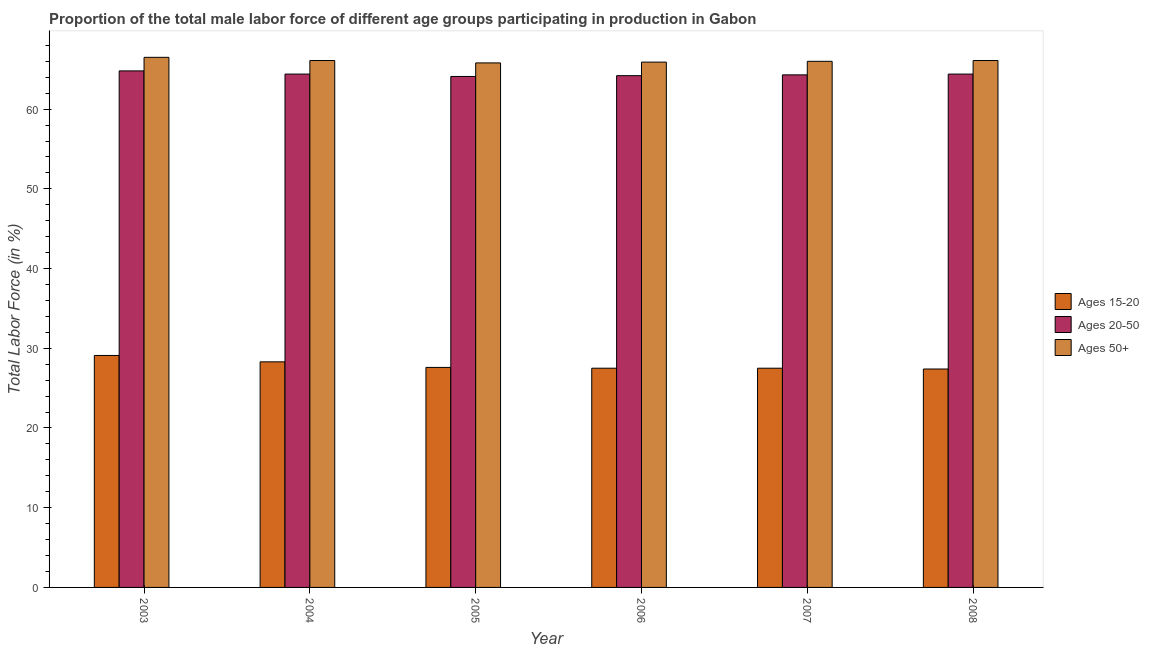How many different coloured bars are there?
Your answer should be very brief. 3. Are the number of bars per tick equal to the number of legend labels?
Provide a succinct answer. Yes. What is the percentage of male labor force above age 50 in 2003?
Provide a short and direct response. 66.5. Across all years, what is the maximum percentage of male labor force within the age group 20-50?
Provide a short and direct response. 64.8. Across all years, what is the minimum percentage of male labor force above age 50?
Your response must be concise. 65.8. In which year was the percentage of male labor force within the age group 15-20 minimum?
Your answer should be compact. 2008. What is the total percentage of male labor force within the age group 15-20 in the graph?
Ensure brevity in your answer.  167.4. What is the difference between the percentage of male labor force within the age group 15-20 in 2005 and that in 2006?
Keep it short and to the point. 0.1. What is the difference between the percentage of male labor force above age 50 in 2007 and the percentage of male labor force within the age group 20-50 in 2004?
Make the answer very short. -0.1. What is the average percentage of male labor force above age 50 per year?
Keep it short and to the point. 66.07. In the year 2008, what is the difference between the percentage of male labor force within the age group 20-50 and percentage of male labor force above age 50?
Offer a very short reply. 0. In how many years, is the percentage of male labor force above age 50 greater than 30 %?
Ensure brevity in your answer.  6. What is the ratio of the percentage of male labor force within the age group 20-50 in 2006 to that in 2007?
Offer a very short reply. 1. What is the difference between the highest and the second highest percentage of male labor force within the age group 20-50?
Give a very brief answer. 0.4. What is the difference between the highest and the lowest percentage of male labor force within the age group 20-50?
Offer a terse response. 0.7. In how many years, is the percentage of male labor force above age 50 greater than the average percentage of male labor force above age 50 taken over all years?
Offer a terse response. 3. What does the 1st bar from the left in 2006 represents?
Give a very brief answer. Ages 15-20. What does the 3rd bar from the right in 2003 represents?
Offer a very short reply. Ages 15-20. What is the difference between two consecutive major ticks on the Y-axis?
Make the answer very short. 10. Are the values on the major ticks of Y-axis written in scientific E-notation?
Give a very brief answer. No. Does the graph contain grids?
Make the answer very short. No. What is the title of the graph?
Keep it short and to the point. Proportion of the total male labor force of different age groups participating in production in Gabon. Does "Nuclear sources" appear as one of the legend labels in the graph?
Your answer should be very brief. No. What is the Total Labor Force (in %) in Ages 15-20 in 2003?
Keep it short and to the point. 29.1. What is the Total Labor Force (in %) of Ages 20-50 in 2003?
Provide a succinct answer. 64.8. What is the Total Labor Force (in %) of Ages 50+ in 2003?
Your answer should be compact. 66.5. What is the Total Labor Force (in %) in Ages 15-20 in 2004?
Provide a succinct answer. 28.3. What is the Total Labor Force (in %) of Ages 20-50 in 2004?
Offer a terse response. 64.4. What is the Total Labor Force (in %) of Ages 50+ in 2004?
Your answer should be compact. 66.1. What is the Total Labor Force (in %) in Ages 15-20 in 2005?
Ensure brevity in your answer.  27.6. What is the Total Labor Force (in %) of Ages 20-50 in 2005?
Offer a terse response. 64.1. What is the Total Labor Force (in %) of Ages 50+ in 2005?
Offer a very short reply. 65.8. What is the Total Labor Force (in %) of Ages 15-20 in 2006?
Ensure brevity in your answer.  27.5. What is the Total Labor Force (in %) in Ages 20-50 in 2006?
Offer a very short reply. 64.2. What is the Total Labor Force (in %) in Ages 50+ in 2006?
Keep it short and to the point. 65.9. What is the Total Labor Force (in %) in Ages 15-20 in 2007?
Your response must be concise. 27.5. What is the Total Labor Force (in %) in Ages 20-50 in 2007?
Your answer should be very brief. 64.3. What is the Total Labor Force (in %) of Ages 50+ in 2007?
Make the answer very short. 66. What is the Total Labor Force (in %) in Ages 15-20 in 2008?
Your response must be concise. 27.4. What is the Total Labor Force (in %) in Ages 20-50 in 2008?
Your answer should be compact. 64.4. What is the Total Labor Force (in %) of Ages 50+ in 2008?
Offer a very short reply. 66.1. Across all years, what is the maximum Total Labor Force (in %) of Ages 15-20?
Provide a short and direct response. 29.1. Across all years, what is the maximum Total Labor Force (in %) in Ages 20-50?
Make the answer very short. 64.8. Across all years, what is the maximum Total Labor Force (in %) of Ages 50+?
Your answer should be compact. 66.5. Across all years, what is the minimum Total Labor Force (in %) of Ages 15-20?
Offer a terse response. 27.4. Across all years, what is the minimum Total Labor Force (in %) of Ages 20-50?
Keep it short and to the point. 64.1. Across all years, what is the minimum Total Labor Force (in %) of Ages 50+?
Your answer should be compact. 65.8. What is the total Total Labor Force (in %) in Ages 15-20 in the graph?
Give a very brief answer. 167.4. What is the total Total Labor Force (in %) in Ages 20-50 in the graph?
Make the answer very short. 386.2. What is the total Total Labor Force (in %) in Ages 50+ in the graph?
Your response must be concise. 396.4. What is the difference between the Total Labor Force (in %) of Ages 15-20 in 2003 and that in 2004?
Provide a succinct answer. 0.8. What is the difference between the Total Labor Force (in %) of Ages 50+ in 2003 and that in 2004?
Provide a succinct answer. 0.4. What is the difference between the Total Labor Force (in %) of Ages 15-20 in 2003 and that in 2005?
Make the answer very short. 1.5. What is the difference between the Total Labor Force (in %) of Ages 50+ in 2003 and that in 2005?
Your answer should be compact. 0.7. What is the difference between the Total Labor Force (in %) of Ages 20-50 in 2003 and that in 2007?
Offer a very short reply. 0.5. What is the difference between the Total Labor Force (in %) of Ages 50+ in 2003 and that in 2007?
Provide a short and direct response. 0.5. What is the difference between the Total Labor Force (in %) of Ages 20-50 in 2003 and that in 2008?
Provide a succinct answer. 0.4. What is the difference between the Total Labor Force (in %) of Ages 50+ in 2003 and that in 2008?
Keep it short and to the point. 0.4. What is the difference between the Total Labor Force (in %) in Ages 15-20 in 2004 and that in 2005?
Give a very brief answer. 0.7. What is the difference between the Total Labor Force (in %) in Ages 50+ in 2004 and that in 2005?
Your response must be concise. 0.3. What is the difference between the Total Labor Force (in %) of Ages 15-20 in 2004 and that in 2006?
Offer a terse response. 0.8. What is the difference between the Total Labor Force (in %) in Ages 50+ in 2004 and that in 2006?
Provide a short and direct response. 0.2. What is the difference between the Total Labor Force (in %) of Ages 20-50 in 2004 and that in 2007?
Offer a very short reply. 0.1. What is the difference between the Total Labor Force (in %) of Ages 50+ in 2004 and that in 2007?
Give a very brief answer. 0.1. What is the difference between the Total Labor Force (in %) of Ages 15-20 in 2004 and that in 2008?
Keep it short and to the point. 0.9. What is the difference between the Total Labor Force (in %) of Ages 50+ in 2004 and that in 2008?
Your response must be concise. 0. What is the difference between the Total Labor Force (in %) in Ages 20-50 in 2005 and that in 2006?
Make the answer very short. -0.1. What is the difference between the Total Labor Force (in %) of Ages 50+ in 2005 and that in 2006?
Give a very brief answer. -0.1. What is the difference between the Total Labor Force (in %) in Ages 15-20 in 2005 and that in 2007?
Provide a short and direct response. 0.1. What is the difference between the Total Labor Force (in %) of Ages 20-50 in 2005 and that in 2007?
Your answer should be very brief. -0.2. What is the difference between the Total Labor Force (in %) of Ages 20-50 in 2005 and that in 2008?
Offer a very short reply. -0.3. What is the difference between the Total Labor Force (in %) in Ages 50+ in 2005 and that in 2008?
Your answer should be very brief. -0.3. What is the difference between the Total Labor Force (in %) in Ages 15-20 in 2006 and that in 2007?
Provide a succinct answer. 0. What is the difference between the Total Labor Force (in %) of Ages 20-50 in 2006 and that in 2007?
Offer a very short reply. -0.1. What is the difference between the Total Labor Force (in %) in Ages 15-20 in 2006 and that in 2008?
Keep it short and to the point. 0.1. What is the difference between the Total Labor Force (in %) of Ages 20-50 in 2006 and that in 2008?
Provide a short and direct response. -0.2. What is the difference between the Total Labor Force (in %) of Ages 50+ in 2006 and that in 2008?
Keep it short and to the point. -0.2. What is the difference between the Total Labor Force (in %) of Ages 15-20 in 2007 and that in 2008?
Your response must be concise. 0.1. What is the difference between the Total Labor Force (in %) in Ages 50+ in 2007 and that in 2008?
Your response must be concise. -0.1. What is the difference between the Total Labor Force (in %) in Ages 15-20 in 2003 and the Total Labor Force (in %) in Ages 20-50 in 2004?
Keep it short and to the point. -35.3. What is the difference between the Total Labor Force (in %) in Ages 15-20 in 2003 and the Total Labor Force (in %) in Ages 50+ in 2004?
Ensure brevity in your answer.  -37. What is the difference between the Total Labor Force (in %) in Ages 15-20 in 2003 and the Total Labor Force (in %) in Ages 20-50 in 2005?
Keep it short and to the point. -35. What is the difference between the Total Labor Force (in %) of Ages 15-20 in 2003 and the Total Labor Force (in %) of Ages 50+ in 2005?
Your answer should be very brief. -36.7. What is the difference between the Total Labor Force (in %) in Ages 20-50 in 2003 and the Total Labor Force (in %) in Ages 50+ in 2005?
Ensure brevity in your answer.  -1. What is the difference between the Total Labor Force (in %) of Ages 15-20 in 2003 and the Total Labor Force (in %) of Ages 20-50 in 2006?
Offer a terse response. -35.1. What is the difference between the Total Labor Force (in %) of Ages 15-20 in 2003 and the Total Labor Force (in %) of Ages 50+ in 2006?
Your answer should be compact. -36.8. What is the difference between the Total Labor Force (in %) of Ages 15-20 in 2003 and the Total Labor Force (in %) of Ages 20-50 in 2007?
Make the answer very short. -35.2. What is the difference between the Total Labor Force (in %) in Ages 15-20 in 2003 and the Total Labor Force (in %) in Ages 50+ in 2007?
Your response must be concise. -36.9. What is the difference between the Total Labor Force (in %) of Ages 20-50 in 2003 and the Total Labor Force (in %) of Ages 50+ in 2007?
Your answer should be very brief. -1.2. What is the difference between the Total Labor Force (in %) of Ages 15-20 in 2003 and the Total Labor Force (in %) of Ages 20-50 in 2008?
Your response must be concise. -35.3. What is the difference between the Total Labor Force (in %) in Ages 15-20 in 2003 and the Total Labor Force (in %) in Ages 50+ in 2008?
Ensure brevity in your answer.  -37. What is the difference between the Total Labor Force (in %) in Ages 15-20 in 2004 and the Total Labor Force (in %) in Ages 20-50 in 2005?
Offer a very short reply. -35.8. What is the difference between the Total Labor Force (in %) in Ages 15-20 in 2004 and the Total Labor Force (in %) in Ages 50+ in 2005?
Your answer should be compact. -37.5. What is the difference between the Total Labor Force (in %) of Ages 20-50 in 2004 and the Total Labor Force (in %) of Ages 50+ in 2005?
Your response must be concise. -1.4. What is the difference between the Total Labor Force (in %) of Ages 15-20 in 2004 and the Total Labor Force (in %) of Ages 20-50 in 2006?
Make the answer very short. -35.9. What is the difference between the Total Labor Force (in %) of Ages 15-20 in 2004 and the Total Labor Force (in %) of Ages 50+ in 2006?
Offer a very short reply. -37.6. What is the difference between the Total Labor Force (in %) in Ages 15-20 in 2004 and the Total Labor Force (in %) in Ages 20-50 in 2007?
Provide a short and direct response. -36. What is the difference between the Total Labor Force (in %) in Ages 15-20 in 2004 and the Total Labor Force (in %) in Ages 50+ in 2007?
Your response must be concise. -37.7. What is the difference between the Total Labor Force (in %) of Ages 20-50 in 2004 and the Total Labor Force (in %) of Ages 50+ in 2007?
Ensure brevity in your answer.  -1.6. What is the difference between the Total Labor Force (in %) in Ages 15-20 in 2004 and the Total Labor Force (in %) in Ages 20-50 in 2008?
Ensure brevity in your answer.  -36.1. What is the difference between the Total Labor Force (in %) of Ages 15-20 in 2004 and the Total Labor Force (in %) of Ages 50+ in 2008?
Your answer should be very brief. -37.8. What is the difference between the Total Labor Force (in %) of Ages 15-20 in 2005 and the Total Labor Force (in %) of Ages 20-50 in 2006?
Your answer should be compact. -36.6. What is the difference between the Total Labor Force (in %) of Ages 15-20 in 2005 and the Total Labor Force (in %) of Ages 50+ in 2006?
Your answer should be very brief. -38.3. What is the difference between the Total Labor Force (in %) in Ages 20-50 in 2005 and the Total Labor Force (in %) in Ages 50+ in 2006?
Your response must be concise. -1.8. What is the difference between the Total Labor Force (in %) in Ages 15-20 in 2005 and the Total Labor Force (in %) in Ages 20-50 in 2007?
Give a very brief answer. -36.7. What is the difference between the Total Labor Force (in %) of Ages 15-20 in 2005 and the Total Labor Force (in %) of Ages 50+ in 2007?
Your answer should be compact. -38.4. What is the difference between the Total Labor Force (in %) in Ages 20-50 in 2005 and the Total Labor Force (in %) in Ages 50+ in 2007?
Offer a very short reply. -1.9. What is the difference between the Total Labor Force (in %) of Ages 15-20 in 2005 and the Total Labor Force (in %) of Ages 20-50 in 2008?
Provide a succinct answer. -36.8. What is the difference between the Total Labor Force (in %) in Ages 15-20 in 2005 and the Total Labor Force (in %) in Ages 50+ in 2008?
Give a very brief answer. -38.5. What is the difference between the Total Labor Force (in %) in Ages 20-50 in 2005 and the Total Labor Force (in %) in Ages 50+ in 2008?
Keep it short and to the point. -2. What is the difference between the Total Labor Force (in %) in Ages 15-20 in 2006 and the Total Labor Force (in %) in Ages 20-50 in 2007?
Your answer should be compact. -36.8. What is the difference between the Total Labor Force (in %) in Ages 15-20 in 2006 and the Total Labor Force (in %) in Ages 50+ in 2007?
Provide a succinct answer. -38.5. What is the difference between the Total Labor Force (in %) in Ages 15-20 in 2006 and the Total Labor Force (in %) in Ages 20-50 in 2008?
Offer a terse response. -36.9. What is the difference between the Total Labor Force (in %) of Ages 15-20 in 2006 and the Total Labor Force (in %) of Ages 50+ in 2008?
Your answer should be very brief. -38.6. What is the difference between the Total Labor Force (in %) of Ages 15-20 in 2007 and the Total Labor Force (in %) of Ages 20-50 in 2008?
Make the answer very short. -36.9. What is the difference between the Total Labor Force (in %) of Ages 15-20 in 2007 and the Total Labor Force (in %) of Ages 50+ in 2008?
Make the answer very short. -38.6. What is the difference between the Total Labor Force (in %) of Ages 20-50 in 2007 and the Total Labor Force (in %) of Ages 50+ in 2008?
Offer a very short reply. -1.8. What is the average Total Labor Force (in %) of Ages 15-20 per year?
Give a very brief answer. 27.9. What is the average Total Labor Force (in %) of Ages 20-50 per year?
Provide a short and direct response. 64.37. What is the average Total Labor Force (in %) in Ages 50+ per year?
Offer a very short reply. 66.07. In the year 2003, what is the difference between the Total Labor Force (in %) in Ages 15-20 and Total Labor Force (in %) in Ages 20-50?
Offer a terse response. -35.7. In the year 2003, what is the difference between the Total Labor Force (in %) in Ages 15-20 and Total Labor Force (in %) in Ages 50+?
Your answer should be compact. -37.4. In the year 2003, what is the difference between the Total Labor Force (in %) of Ages 20-50 and Total Labor Force (in %) of Ages 50+?
Give a very brief answer. -1.7. In the year 2004, what is the difference between the Total Labor Force (in %) in Ages 15-20 and Total Labor Force (in %) in Ages 20-50?
Offer a terse response. -36.1. In the year 2004, what is the difference between the Total Labor Force (in %) in Ages 15-20 and Total Labor Force (in %) in Ages 50+?
Provide a short and direct response. -37.8. In the year 2005, what is the difference between the Total Labor Force (in %) of Ages 15-20 and Total Labor Force (in %) of Ages 20-50?
Offer a terse response. -36.5. In the year 2005, what is the difference between the Total Labor Force (in %) of Ages 15-20 and Total Labor Force (in %) of Ages 50+?
Your answer should be compact. -38.2. In the year 2005, what is the difference between the Total Labor Force (in %) of Ages 20-50 and Total Labor Force (in %) of Ages 50+?
Keep it short and to the point. -1.7. In the year 2006, what is the difference between the Total Labor Force (in %) of Ages 15-20 and Total Labor Force (in %) of Ages 20-50?
Provide a succinct answer. -36.7. In the year 2006, what is the difference between the Total Labor Force (in %) of Ages 15-20 and Total Labor Force (in %) of Ages 50+?
Your answer should be compact. -38.4. In the year 2007, what is the difference between the Total Labor Force (in %) of Ages 15-20 and Total Labor Force (in %) of Ages 20-50?
Ensure brevity in your answer.  -36.8. In the year 2007, what is the difference between the Total Labor Force (in %) of Ages 15-20 and Total Labor Force (in %) of Ages 50+?
Offer a terse response. -38.5. In the year 2007, what is the difference between the Total Labor Force (in %) in Ages 20-50 and Total Labor Force (in %) in Ages 50+?
Offer a terse response. -1.7. In the year 2008, what is the difference between the Total Labor Force (in %) of Ages 15-20 and Total Labor Force (in %) of Ages 20-50?
Provide a short and direct response. -37. In the year 2008, what is the difference between the Total Labor Force (in %) of Ages 15-20 and Total Labor Force (in %) of Ages 50+?
Your answer should be compact. -38.7. In the year 2008, what is the difference between the Total Labor Force (in %) of Ages 20-50 and Total Labor Force (in %) of Ages 50+?
Your answer should be very brief. -1.7. What is the ratio of the Total Labor Force (in %) of Ages 15-20 in 2003 to that in 2004?
Offer a very short reply. 1.03. What is the ratio of the Total Labor Force (in %) of Ages 15-20 in 2003 to that in 2005?
Provide a succinct answer. 1.05. What is the ratio of the Total Labor Force (in %) of Ages 20-50 in 2003 to that in 2005?
Make the answer very short. 1.01. What is the ratio of the Total Labor Force (in %) in Ages 50+ in 2003 to that in 2005?
Your response must be concise. 1.01. What is the ratio of the Total Labor Force (in %) of Ages 15-20 in 2003 to that in 2006?
Give a very brief answer. 1.06. What is the ratio of the Total Labor Force (in %) in Ages 20-50 in 2003 to that in 2006?
Your answer should be very brief. 1.01. What is the ratio of the Total Labor Force (in %) in Ages 50+ in 2003 to that in 2006?
Your response must be concise. 1.01. What is the ratio of the Total Labor Force (in %) of Ages 15-20 in 2003 to that in 2007?
Your answer should be compact. 1.06. What is the ratio of the Total Labor Force (in %) in Ages 50+ in 2003 to that in 2007?
Make the answer very short. 1.01. What is the ratio of the Total Labor Force (in %) in Ages 15-20 in 2003 to that in 2008?
Offer a very short reply. 1.06. What is the ratio of the Total Labor Force (in %) of Ages 50+ in 2003 to that in 2008?
Your answer should be compact. 1.01. What is the ratio of the Total Labor Force (in %) of Ages 15-20 in 2004 to that in 2005?
Give a very brief answer. 1.03. What is the ratio of the Total Labor Force (in %) in Ages 50+ in 2004 to that in 2005?
Keep it short and to the point. 1. What is the ratio of the Total Labor Force (in %) in Ages 15-20 in 2004 to that in 2006?
Your response must be concise. 1.03. What is the ratio of the Total Labor Force (in %) in Ages 15-20 in 2004 to that in 2007?
Offer a terse response. 1.03. What is the ratio of the Total Labor Force (in %) of Ages 20-50 in 2004 to that in 2007?
Offer a terse response. 1. What is the ratio of the Total Labor Force (in %) in Ages 15-20 in 2004 to that in 2008?
Make the answer very short. 1.03. What is the ratio of the Total Labor Force (in %) in Ages 20-50 in 2004 to that in 2008?
Provide a short and direct response. 1. What is the ratio of the Total Labor Force (in %) in Ages 50+ in 2004 to that in 2008?
Your response must be concise. 1. What is the ratio of the Total Labor Force (in %) of Ages 20-50 in 2005 to that in 2006?
Your response must be concise. 1. What is the ratio of the Total Labor Force (in %) in Ages 15-20 in 2005 to that in 2007?
Offer a terse response. 1. What is the ratio of the Total Labor Force (in %) of Ages 20-50 in 2005 to that in 2007?
Provide a short and direct response. 1. What is the ratio of the Total Labor Force (in %) of Ages 50+ in 2005 to that in 2007?
Make the answer very short. 1. What is the ratio of the Total Labor Force (in %) of Ages 15-20 in 2005 to that in 2008?
Your answer should be very brief. 1.01. What is the ratio of the Total Labor Force (in %) in Ages 20-50 in 2005 to that in 2008?
Give a very brief answer. 1. What is the ratio of the Total Labor Force (in %) in Ages 50+ in 2005 to that in 2008?
Offer a very short reply. 1. What is the ratio of the Total Labor Force (in %) of Ages 20-50 in 2006 to that in 2008?
Offer a very short reply. 1. What is the ratio of the Total Labor Force (in %) in Ages 50+ in 2006 to that in 2008?
Your answer should be very brief. 1. What is the ratio of the Total Labor Force (in %) of Ages 15-20 in 2007 to that in 2008?
Provide a succinct answer. 1. What is the ratio of the Total Labor Force (in %) of Ages 20-50 in 2007 to that in 2008?
Give a very brief answer. 1. What is the difference between the highest and the second highest Total Labor Force (in %) of Ages 20-50?
Offer a terse response. 0.4. What is the difference between the highest and the lowest Total Labor Force (in %) in Ages 15-20?
Your response must be concise. 1.7. What is the difference between the highest and the lowest Total Labor Force (in %) in Ages 20-50?
Ensure brevity in your answer.  0.7. 